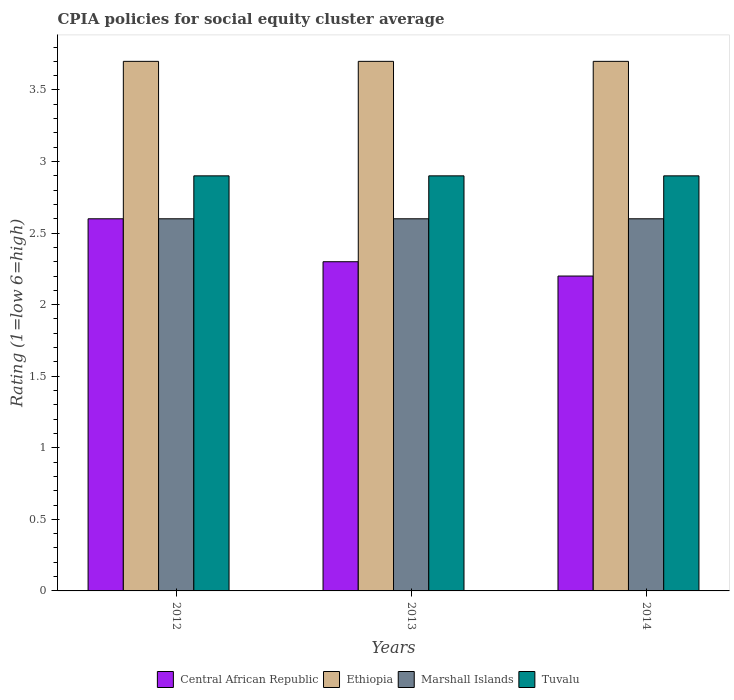Are the number of bars per tick equal to the number of legend labels?
Give a very brief answer. Yes. Are the number of bars on each tick of the X-axis equal?
Give a very brief answer. Yes. How many bars are there on the 1st tick from the left?
Your response must be concise. 4. How many bars are there on the 1st tick from the right?
Keep it short and to the point. 4. What is the CPIA rating in Ethiopia in 2012?
Give a very brief answer. 3.7. Across all years, what is the maximum CPIA rating in Ethiopia?
Your answer should be compact. 3.7. Across all years, what is the minimum CPIA rating in Ethiopia?
Give a very brief answer. 3.7. In which year was the CPIA rating in Marshall Islands maximum?
Provide a short and direct response. 2012. What is the total CPIA rating in Ethiopia in the graph?
Provide a short and direct response. 11.1. What is the difference between the CPIA rating in Tuvalu in 2012 and that in 2014?
Keep it short and to the point. 0. What is the difference between the CPIA rating in Central African Republic in 2012 and the CPIA rating in Ethiopia in 2013?
Give a very brief answer. -1.1. In the year 2013, what is the difference between the CPIA rating in Central African Republic and CPIA rating in Tuvalu?
Give a very brief answer. -0.6. In how many years, is the CPIA rating in Ethiopia greater than 1.1?
Provide a succinct answer. 3. What is the ratio of the CPIA rating in Central African Republic in 2012 to that in 2014?
Provide a succinct answer. 1.18. Is the CPIA rating in Central African Republic in 2012 less than that in 2013?
Give a very brief answer. No. Is the difference between the CPIA rating in Central African Republic in 2013 and 2014 greater than the difference between the CPIA rating in Tuvalu in 2013 and 2014?
Give a very brief answer. Yes. What is the difference between the highest and the second highest CPIA rating in Central African Republic?
Your response must be concise. 0.3. What is the difference between the highest and the lowest CPIA rating in Ethiopia?
Provide a succinct answer. 0. In how many years, is the CPIA rating in Central African Republic greater than the average CPIA rating in Central African Republic taken over all years?
Give a very brief answer. 1. Is the sum of the CPIA rating in Central African Republic in 2012 and 2014 greater than the maximum CPIA rating in Ethiopia across all years?
Your answer should be very brief. Yes. Is it the case that in every year, the sum of the CPIA rating in Ethiopia and CPIA rating in Marshall Islands is greater than the sum of CPIA rating in Tuvalu and CPIA rating in Central African Republic?
Give a very brief answer. Yes. What does the 2nd bar from the left in 2012 represents?
Offer a terse response. Ethiopia. What does the 2nd bar from the right in 2012 represents?
Your answer should be very brief. Marshall Islands. Is it the case that in every year, the sum of the CPIA rating in Marshall Islands and CPIA rating in Ethiopia is greater than the CPIA rating in Tuvalu?
Offer a terse response. Yes. How many years are there in the graph?
Your answer should be very brief. 3. What is the difference between two consecutive major ticks on the Y-axis?
Offer a very short reply. 0.5. Are the values on the major ticks of Y-axis written in scientific E-notation?
Offer a very short reply. No. Does the graph contain any zero values?
Keep it short and to the point. No. Where does the legend appear in the graph?
Make the answer very short. Bottom center. How are the legend labels stacked?
Ensure brevity in your answer.  Horizontal. What is the title of the graph?
Your answer should be very brief. CPIA policies for social equity cluster average. Does "Dominica" appear as one of the legend labels in the graph?
Your answer should be very brief. No. What is the label or title of the X-axis?
Make the answer very short. Years. What is the Rating (1=low 6=high) in Central African Republic in 2012?
Keep it short and to the point. 2.6. What is the Rating (1=low 6=high) in Tuvalu in 2012?
Give a very brief answer. 2.9. What is the Rating (1=low 6=high) in Central African Republic in 2014?
Keep it short and to the point. 2.2. What is the Rating (1=low 6=high) in Ethiopia in 2014?
Make the answer very short. 3.7. Across all years, what is the maximum Rating (1=low 6=high) of Marshall Islands?
Offer a terse response. 2.6. Across all years, what is the maximum Rating (1=low 6=high) in Tuvalu?
Your response must be concise. 2.9. Across all years, what is the minimum Rating (1=low 6=high) of Central African Republic?
Ensure brevity in your answer.  2.2. Across all years, what is the minimum Rating (1=low 6=high) of Marshall Islands?
Your response must be concise. 2.6. What is the total Rating (1=low 6=high) of Marshall Islands in the graph?
Offer a terse response. 7.8. What is the difference between the Rating (1=low 6=high) in Central African Republic in 2012 and that in 2013?
Provide a short and direct response. 0.3. What is the difference between the Rating (1=low 6=high) in Tuvalu in 2012 and that in 2013?
Ensure brevity in your answer.  0. What is the difference between the Rating (1=low 6=high) in Ethiopia in 2012 and that in 2014?
Provide a short and direct response. 0. What is the difference between the Rating (1=low 6=high) in Marshall Islands in 2012 and that in 2014?
Keep it short and to the point. 0. What is the difference between the Rating (1=low 6=high) in Central African Republic in 2013 and that in 2014?
Keep it short and to the point. 0.1. What is the difference between the Rating (1=low 6=high) of Ethiopia in 2013 and that in 2014?
Offer a very short reply. 0. What is the difference between the Rating (1=low 6=high) of Marshall Islands in 2013 and that in 2014?
Keep it short and to the point. 0. What is the difference between the Rating (1=low 6=high) of Central African Republic in 2012 and the Rating (1=low 6=high) of Ethiopia in 2013?
Offer a very short reply. -1.1. What is the difference between the Rating (1=low 6=high) of Central African Republic in 2012 and the Rating (1=low 6=high) of Marshall Islands in 2013?
Provide a succinct answer. 0. What is the difference between the Rating (1=low 6=high) of Central African Republic in 2012 and the Rating (1=low 6=high) of Tuvalu in 2013?
Your answer should be very brief. -0.3. What is the difference between the Rating (1=low 6=high) in Ethiopia in 2012 and the Rating (1=low 6=high) in Marshall Islands in 2013?
Keep it short and to the point. 1.1. What is the difference between the Rating (1=low 6=high) of Ethiopia in 2012 and the Rating (1=low 6=high) of Tuvalu in 2013?
Your response must be concise. 0.8. What is the difference between the Rating (1=low 6=high) of Marshall Islands in 2012 and the Rating (1=low 6=high) of Tuvalu in 2013?
Your answer should be compact. -0.3. What is the difference between the Rating (1=low 6=high) in Central African Republic in 2012 and the Rating (1=low 6=high) in Ethiopia in 2014?
Make the answer very short. -1.1. What is the difference between the Rating (1=low 6=high) in Central African Republic in 2012 and the Rating (1=low 6=high) in Marshall Islands in 2014?
Provide a succinct answer. 0. What is the difference between the Rating (1=low 6=high) in Ethiopia in 2012 and the Rating (1=low 6=high) in Marshall Islands in 2014?
Offer a very short reply. 1.1. What is the difference between the Rating (1=low 6=high) in Marshall Islands in 2012 and the Rating (1=low 6=high) in Tuvalu in 2014?
Provide a succinct answer. -0.3. What is the difference between the Rating (1=low 6=high) of Central African Republic in 2013 and the Rating (1=low 6=high) of Tuvalu in 2014?
Give a very brief answer. -0.6. What is the difference between the Rating (1=low 6=high) in Ethiopia in 2013 and the Rating (1=low 6=high) in Marshall Islands in 2014?
Give a very brief answer. 1.1. What is the difference between the Rating (1=low 6=high) in Ethiopia in 2013 and the Rating (1=low 6=high) in Tuvalu in 2014?
Give a very brief answer. 0.8. What is the difference between the Rating (1=low 6=high) in Marshall Islands in 2013 and the Rating (1=low 6=high) in Tuvalu in 2014?
Your answer should be very brief. -0.3. What is the average Rating (1=low 6=high) of Central African Republic per year?
Provide a short and direct response. 2.37. What is the average Rating (1=low 6=high) in Ethiopia per year?
Your response must be concise. 3.7. In the year 2012, what is the difference between the Rating (1=low 6=high) in Central African Republic and Rating (1=low 6=high) in Marshall Islands?
Offer a very short reply. 0. In the year 2012, what is the difference between the Rating (1=low 6=high) of Central African Republic and Rating (1=low 6=high) of Tuvalu?
Ensure brevity in your answer.  -0.3. In the year 2012, what is the difference between the Rating (1=low 6=high) in Marshall Islands and Rating (1=low 6=high) in Tuvalu?
Offer a very short reply. -0.3. In the year 2013, what is the difference between the Rating (1=low 6=high) in Central African Republic and Rating (1=low 6=high) in Ethiopia?
Your response must be concise. -1.4. In the year 2013, what is the difference between the Rating (1=low 6=high) in Ethiopia and Rating (1=low 6=high) in Marshall Islands?
Provide a succinct answer. 1.1. In the year 2013, what is the difference between the Rating (1=low 6=high) in Ethiopia and Rating (1=low 6=high) in Tuvalu?
Your answer should be very brief. 0.8. In the year 2013, what is the difference between the Rating (1=low 6=high) in Marshall Islands and Rating (1=low 6=high) in Tuvalu?
Keep it short and to the point. -0.3. In the year 2014, what is the difference between the Rating (1=low 6=high) of Central African Republic and Rating (1=low 6=high) of Ethiopia?
Give a very brief answer. -1.5. In the year 2014, what is the difference between the Rating (1=low 6=high) of Central African Republic and Rating (1=low 6=high) of Marshall Islands?
Your response must be concise. -0.4. In the year 2014, what is the difference between the Rating (1=low 6=high) in Ethiopia and Rating (1=low 6=high) in Marshall Islands?
Offer a very short reply. 1.1. In the year 2014, what is the difference between the Rating (1=low 6=high) in Ethiopia and Rating (1=low 6=high) in Tuvalu?
Your answer should be very brief. 0.8. What is the ratio of the Rating (1=low 6=high) of Central African Republic in 2012 to that in 2013?
Offer a very short reply. 1.13. What is the ratio of the Rating (1=low 6=high) of Ethiopia in 2012 to that in 2013?
Provide a short and direct response. 1. What is the ratio of the Rating (1=low 6=high) in Tuvalu in 2012 to that in 2013?
Keep it short and to the point. 1. What is the ratio of the Rating (1=low 6=high) of Central African Republic in 2012 to that in 2014?
Offer a terse response. 1.18. What is the ratio of the Rating (1=low 6=high) in Marshall Islands in 2012 to that in 2014?
Provide a succinct answer. 1. What is the ratio of the Rating (1=low 6=high) in Central African Republic in 2013 to that in 2014?
Provide a short and direct response. 1.05. What is the ratio of the Rating (1=low 6=high) of Ethiopia in 2013 to that in 2014?
Offer a very short reply. 1. What is the ratio of the Rating (1=low 6=high) in Marshall Islands in 2013 to that in 2014?
Your response must be concise. 1. What is the ratio of the Rating (1=low 6=high) of Tuvalu in 2013 to that in 2014?
Provide a short and direct response. 1. What is the difference between the highest and the second highest Rating (1=low 6=high) in Central African Republic?
Your response must be concise. 0.3. What is the difference between the highest and the second highest Rating (1=low 6=high) in Tuvalu?
Give a very brief answer. 0. What is the difference between the highest and the lowest Rating (1=low 6=high) in Ethiopia?
Your answer should be very brief. 0. What is the difference between the highest and the lowest Rating (1=low 6=high) of Tuvalu?
Ensure brevity in your answer.  0. 